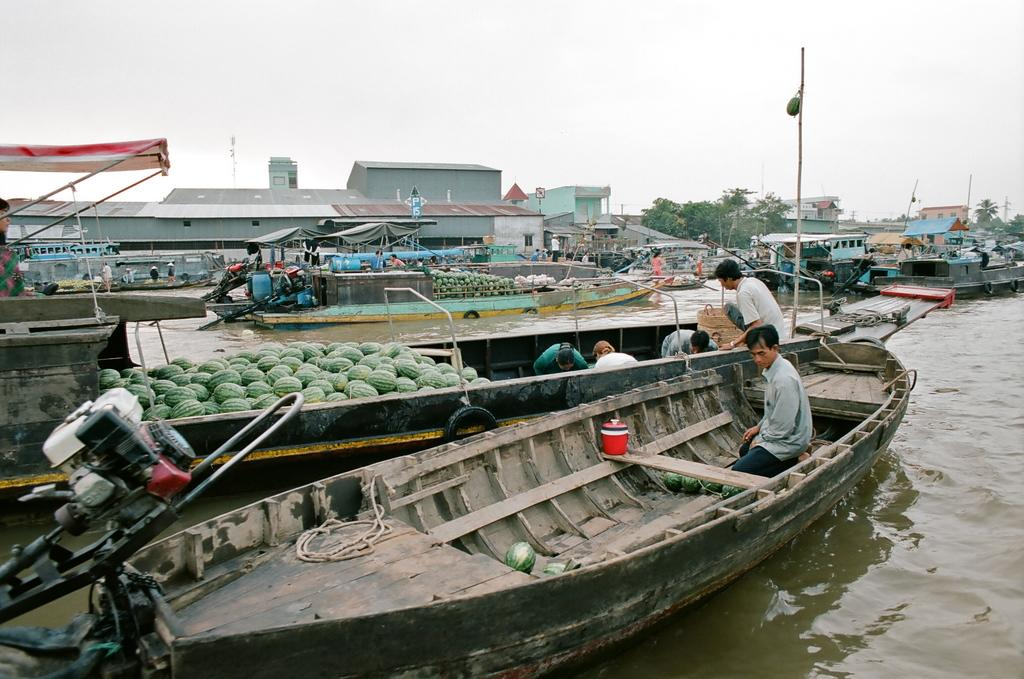What type of vehicles can be seen in the image? There are boats on the water in the image. Can you describe the people visible in the image? There are persons visible in the image. What type of fruit is present in the image? Watermelons are present in the image. What structures can be seen in the image? Poles and houses are visible in the image. What type of surface is present in the image? Boards are present in the image. What type of natural environment is visible in the image? Trees are visible in the image. What is visible in the background of the image? The sky is visible in the background of the image. Where is the doctor standing in the image? There is no doctor present in the image. What type of bomb can be seen in the image? There is no bomb present in the image. 